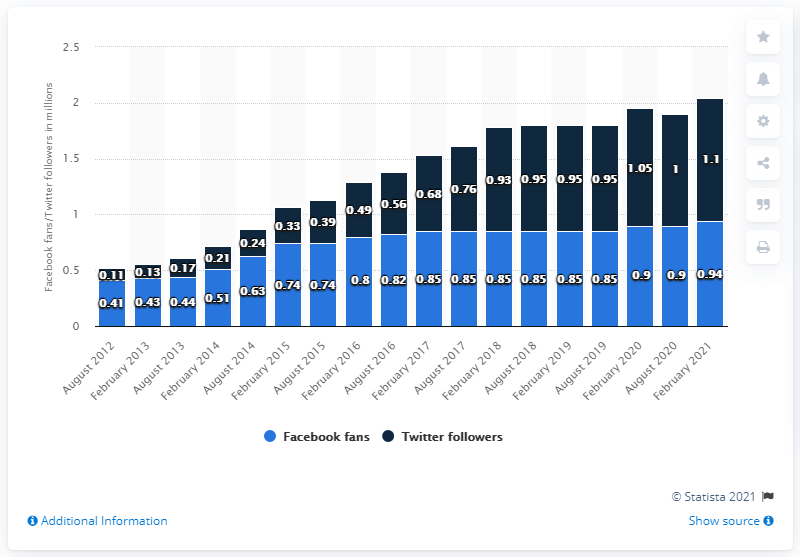Mention a couple of crucial points in this snapshot. The Buffalo Bills had their Facebook page last updated in August 2012. The Buffalo Bills football team had 0.94 Facebook followers in February 2021. The Buffalo Bills' Facebook page reached 0.94 million users in February 2021. 